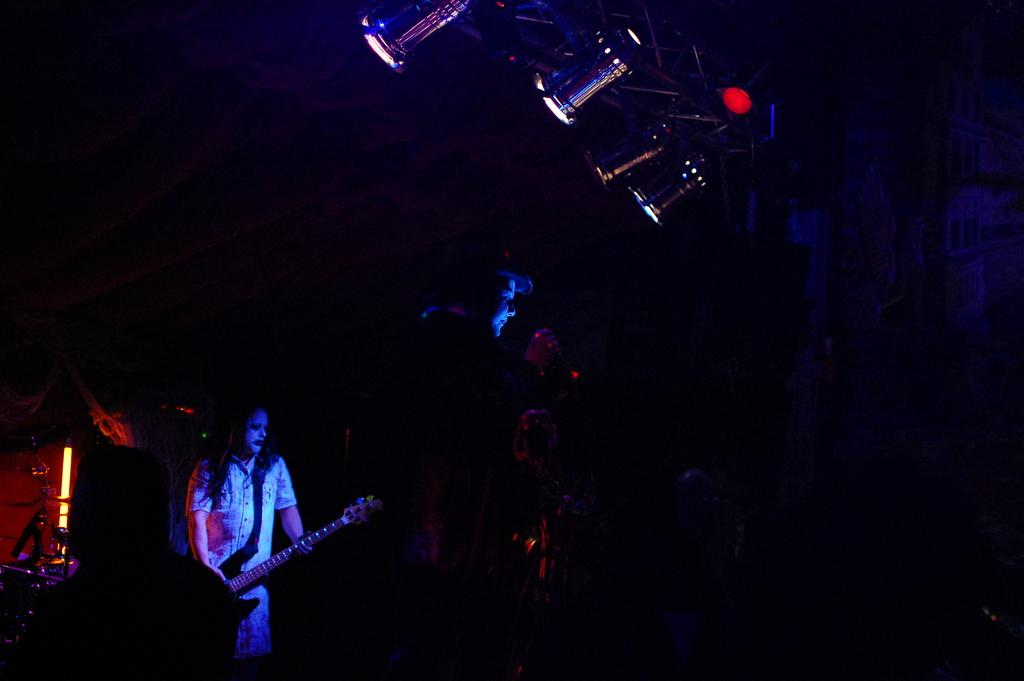Who is the main subject in the image? There is a woman in the image. What is the woman doing in the image? The woman is catching a guitar in the image. What else can be seen in the image besides the woman and the guitar? There are lights visible in the image. What type of jellyfish can be seen swimming in the image? There are no jellyfish present in the image; it features a woman catching a guitar and lights. 